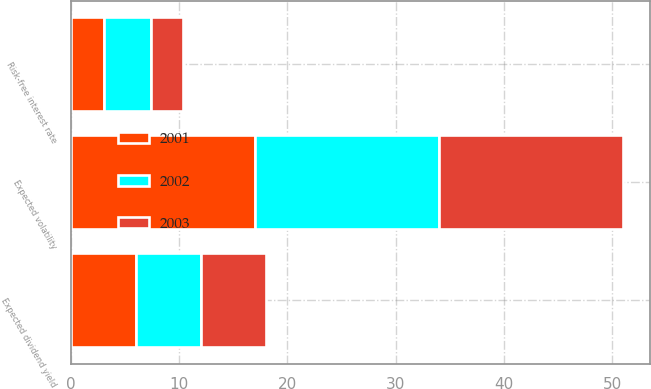Convert chart. <chart><loc_0><loc_0><loc_500><loc_500><stacked_bar_chart><ecel><fcel>Expected volatility<fcel>Risk-free interest rate<fcel>Expected dividend yield<nl><fcel>2003<fcel>17<fcel>2.9<fcel>6<nl><fcel>2001<fcel>17<fcel>3<fcel>6<nl><fcel>2002<fcel>17<fcel>4.4<fcel>6<nl></chart> 